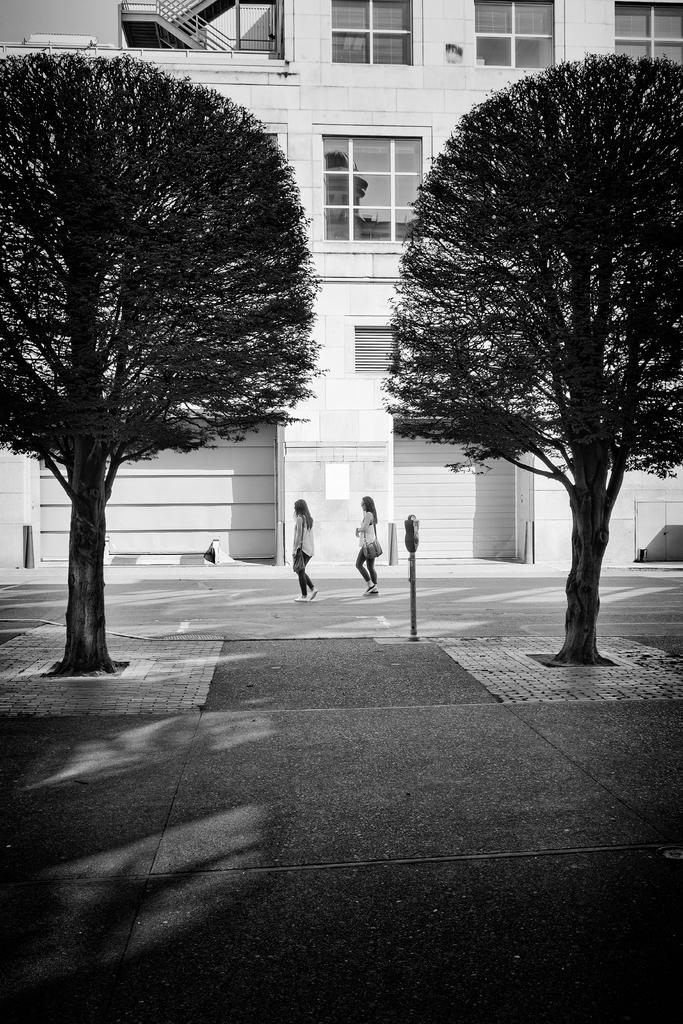How many women are in the image? There are two women in the image. What are the women carrying? The women are carrying bags. What are the women doing in the image? The women are walking on the road. What can be seen in the background of the image? There are trees and a building with windows visible in the background. What type of comb can be seen in the image? There is no comb present in the image. On which side of the road are the women walking? The image does not specify which side of the road the women are walking on. 